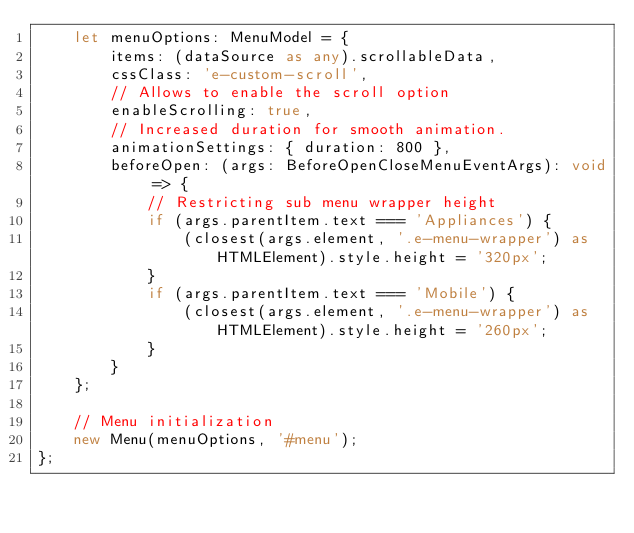<code> <loc_0><loc_0><loc_500><loc_500><_TypeScript_>    let menuOptions: MenuModel = {
        items: (dataSource as any).scrollableData,
        cssClass: 'e-custom-scroll',
        // Allows to enable the scroll option
        enableScrolling: true,
        // Increased duration for smooth animation.
        animationSettings: { duration: 800 },
        beforeOpen: (args: BeforeOpenCloseMenuEventArgs): void => {
            // Restricting sub menu wrapper height
            if (args.parentItem.text === 'Appliances') {
                (closest(args.element, '.e-menu-wrapper') as HTMLElement).style.height = '320px';
            }
            if (args.parentItem.text === 'Mobile') {
                (closest(args.element, '.e-menu-wrapper') as HTMLElement).style.height = '260px';
            }
        }
    };

    // Menu initialization
    new Menu(menuOptions, '#menu');
};
</code> 